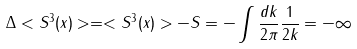<formula> <loc_0><loc_0><loc_500><loc_500>\Delta < S ^ { 3 } ( x ) > = < S ^ { 3 } ( x ) > - S = - \int \frac { d k } { 2 \pi } \frac { 1 } { 2 k } = - \infty</formula> 